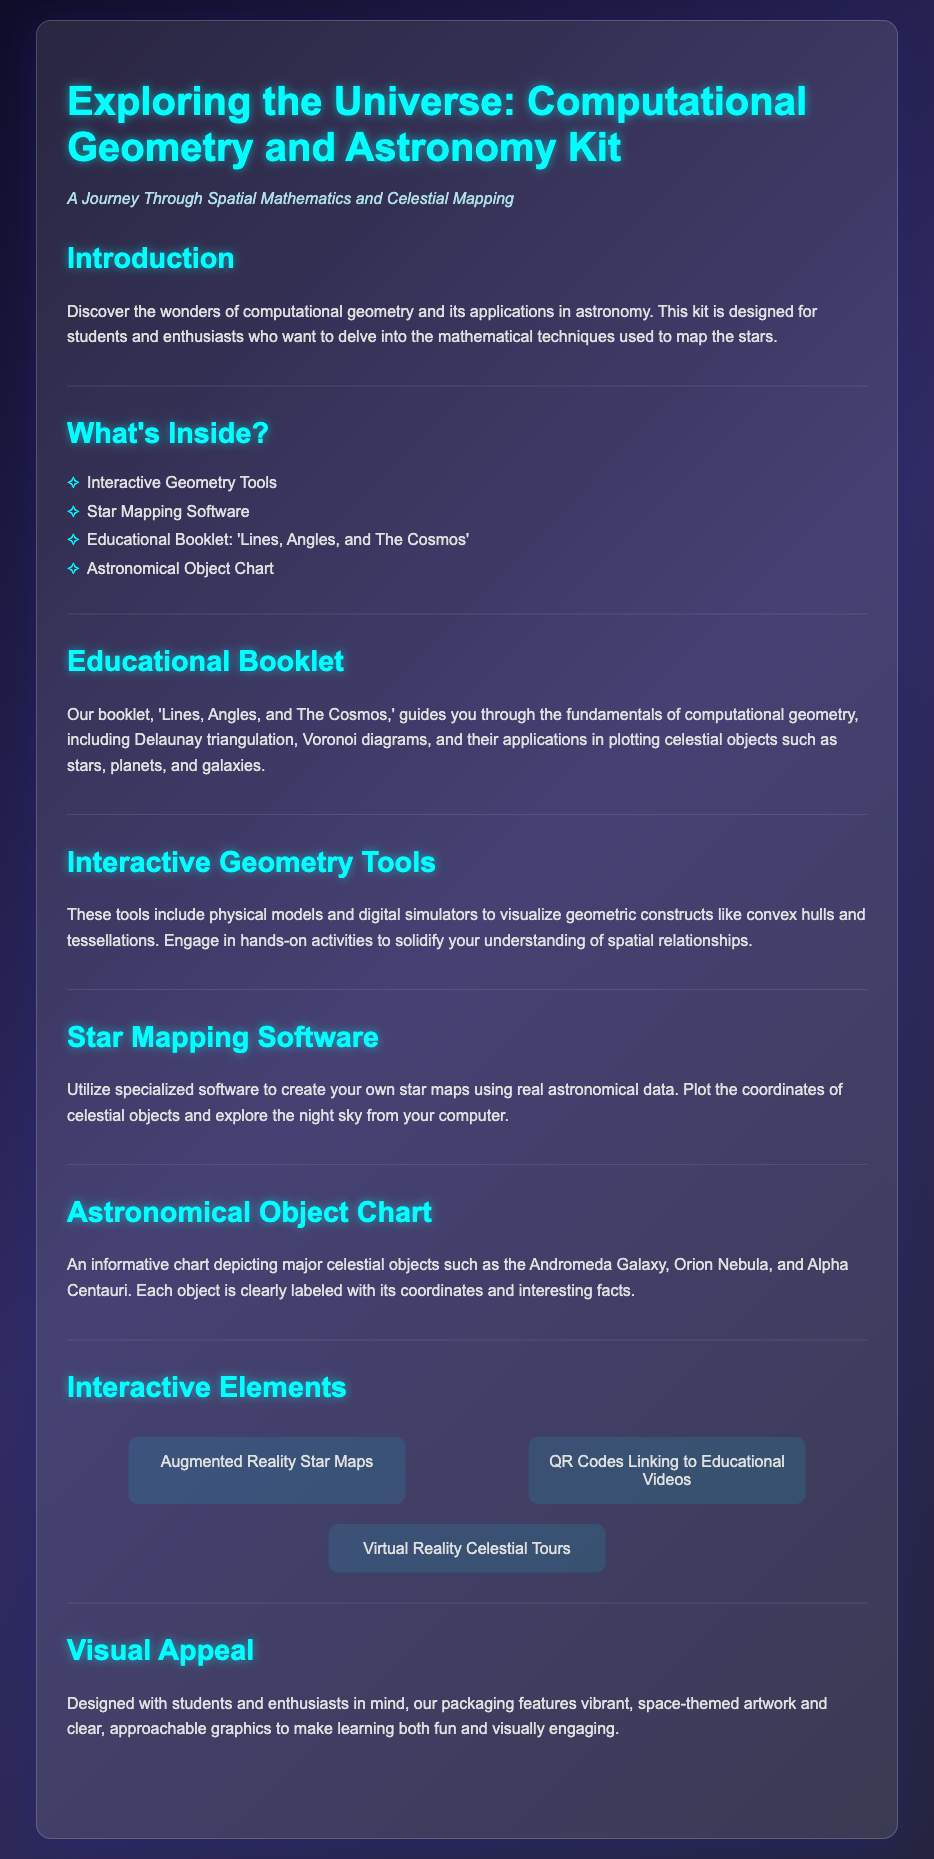What is the title of the kit? The title of the kit is provided as the main heading in the document.
Answer: Exploring the Universe: Computational Geometry and Astronomy Kit Which educational booklet is included? The document specifies that an educational booklet is part of the kit.
Answer: Lines, Angles, and The Cosmos What is one of the interactive elements mentioned? The document lists various interactive elements that enhance the learning experience.
Answer: Augmented Reality Star Maps What type of software is included in the kit? The document mentions specific software included for practical applications.
Answer: Star Mapping Software How many major celestial objects are depicted in the chart? While the document doesn't provide a specific number, it lists a few examples in the description of the chart.
Answer: Three 